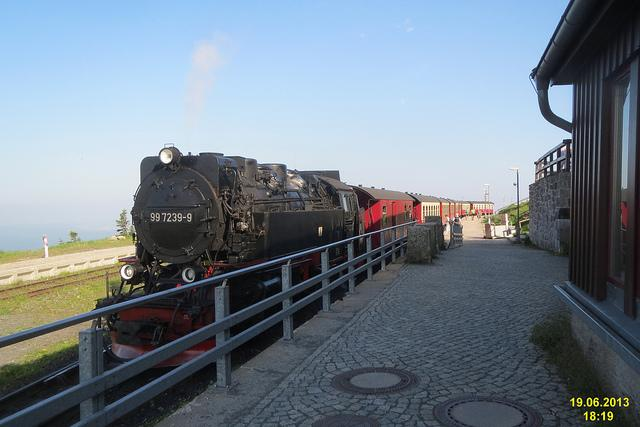Where might someone buy a ticket for this train? Please explain your reasoning. inside building. Train boarding passes are traditionally sold at buildings at the station as we can see here. 